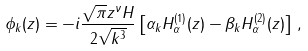Convert formula to latex. <formula><loc_0><loc_0><loc_500><loc_500>\phi _ { k } ( z ) = - i \frac { \sqrt { \pi } z ^ { \nu } H } { 2 \sqrt { k ^ { 3 } } } \left [ \alpha _ { k } H _ { \alpha } ^ { ( 1 ) } ( z ) - \beta _ { k } H _ { \alpha } ^ { ( 2 ) } ( z ) \right ] \, ,</formula> 